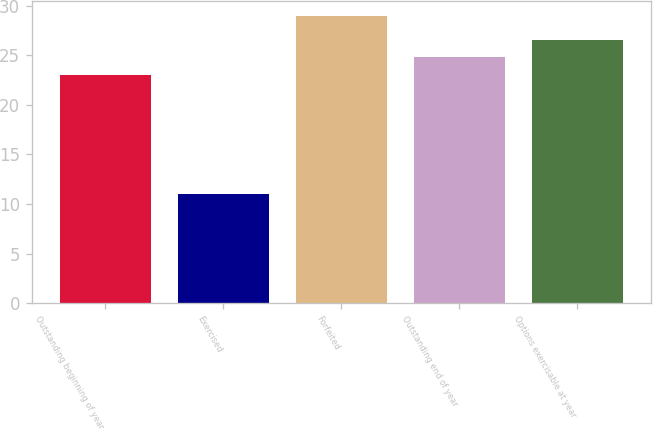Convert chart. <chart><loc_0><loc_0><loc_500><loc_500><bar_chart><fcel>Outstanding beginning of year<fcel>Exercised<fcel>Forfeited<fcel>Outstanding end of year<fcel>Options exercisable at year<nl><fcel>23<fcel>11<fcel>29<fcel>24.8<fcel>26.6<nl></chart> 